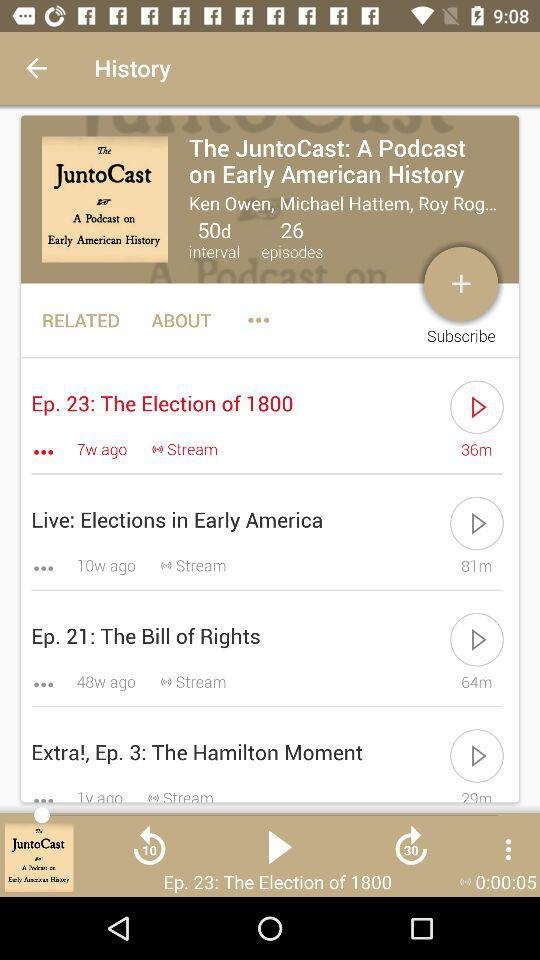What is the name of the selected episode? The name of the selected episode is "The Election of 1800". 